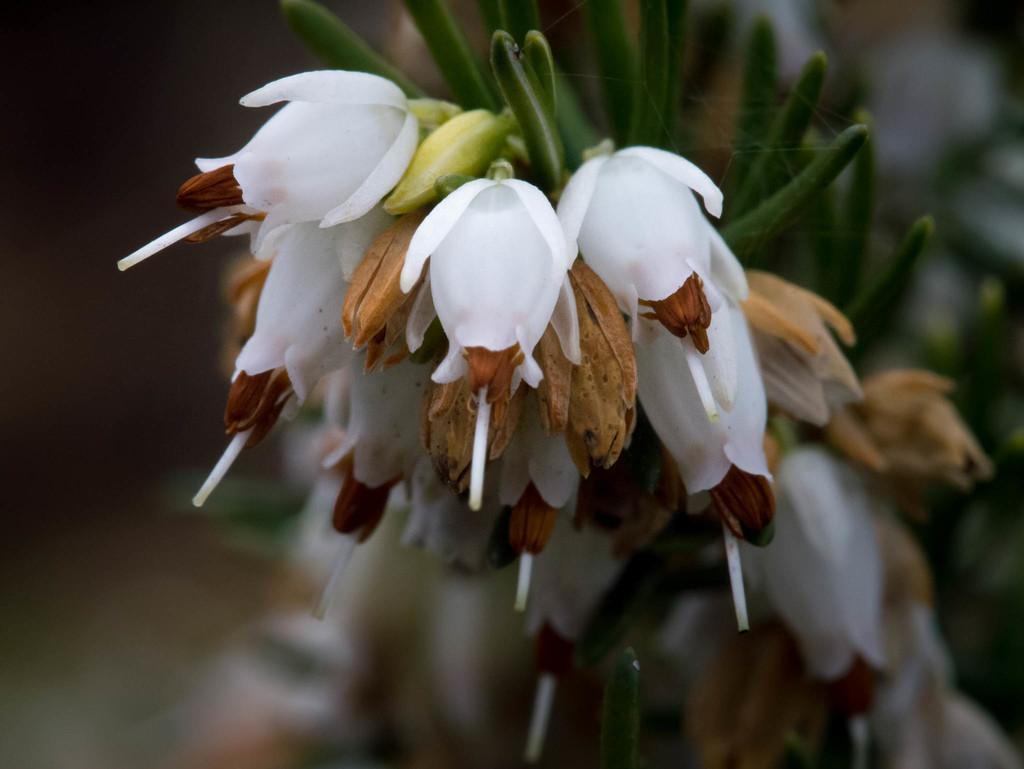Please provide a concise description of this image. In this picture there is a flower in the image. 